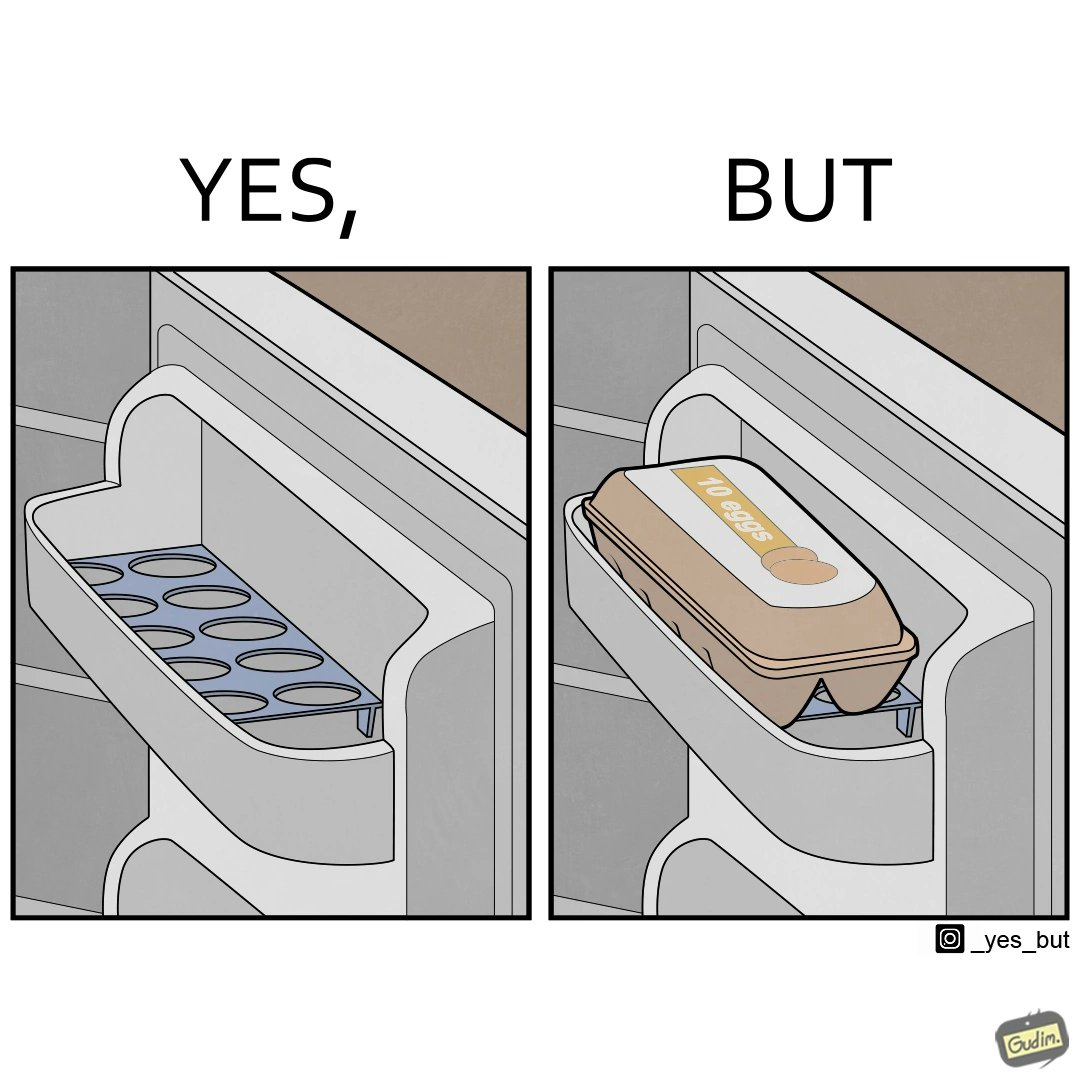What is shown in this image? The images are funny since the show how even though refrigerator manufacturers design in-built egg trays, they are of no use to users who choose to put their entire box of eggs in the refrigerator 